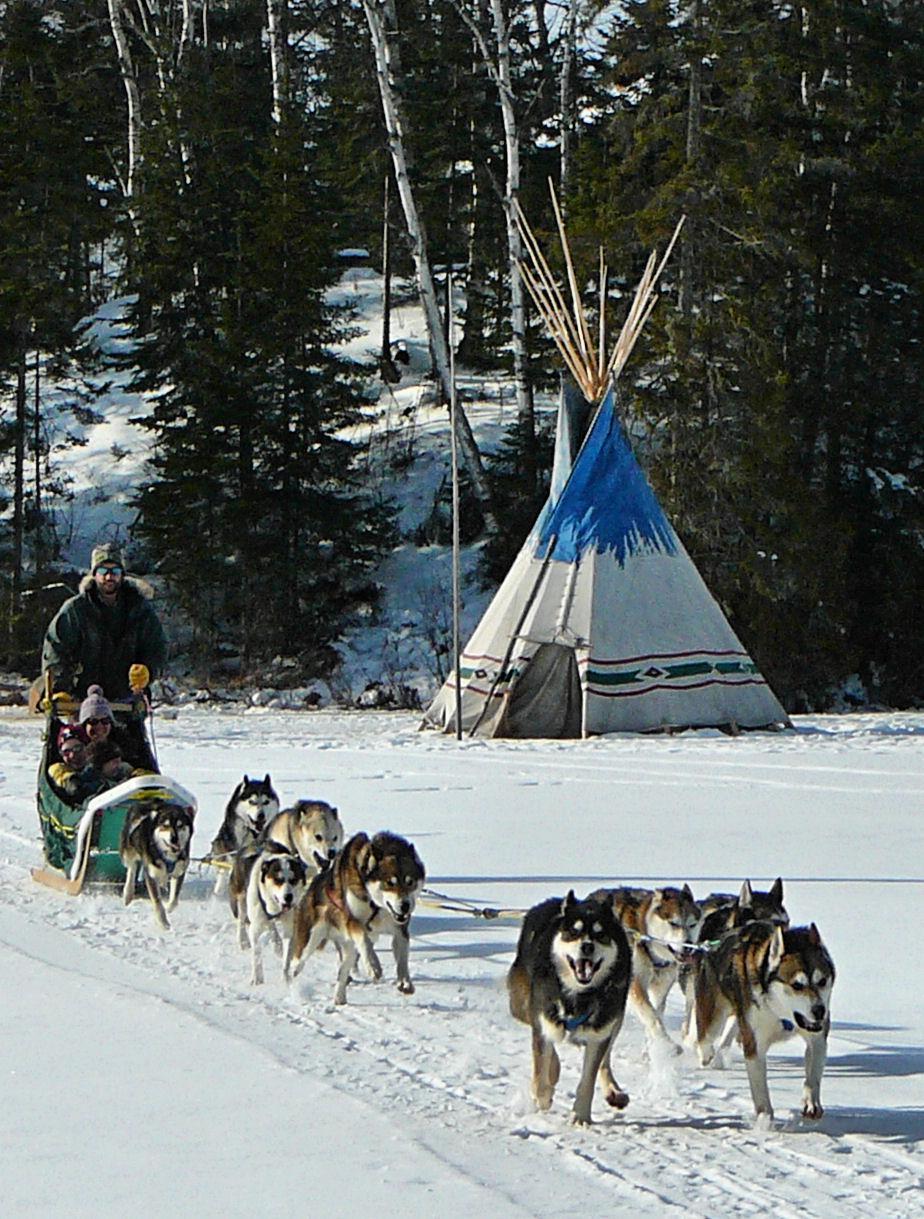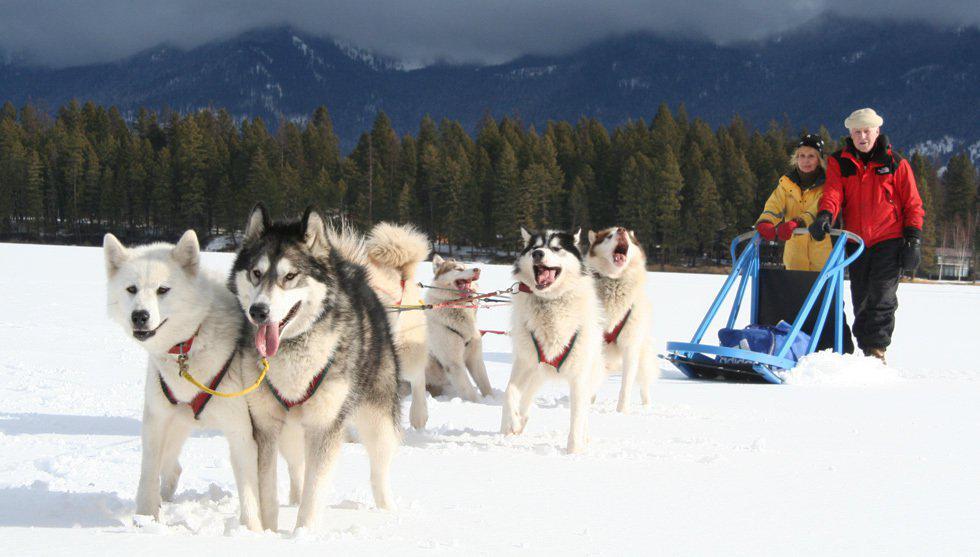The first image is the image on the left, the second image is the image on the right. Assess this claim about the two images: "The dog sled teams in the left and right images appear to be heading toward each other.". Correct or not? Answer yes or no. Yes. 